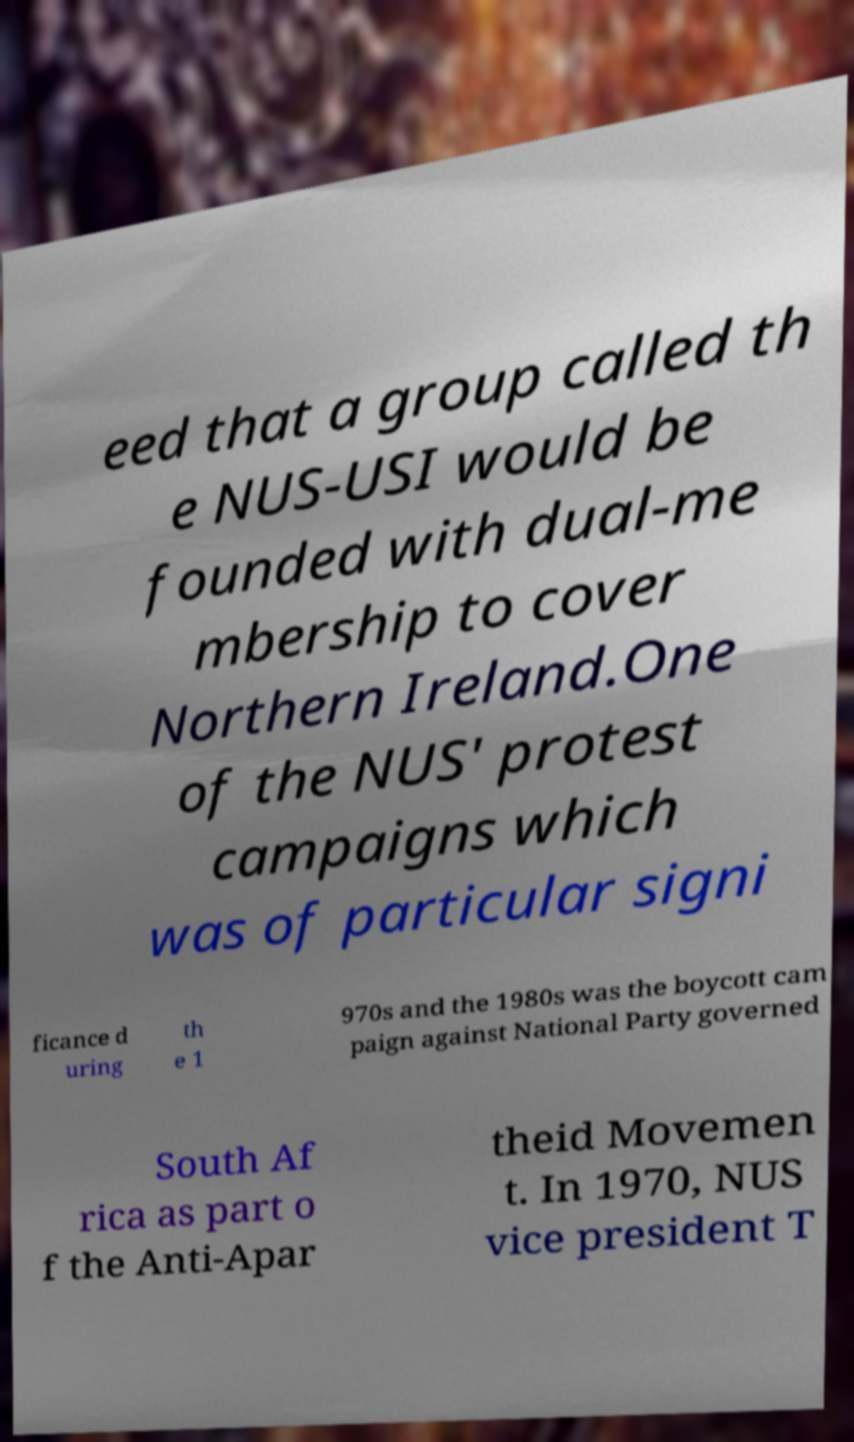There's text embedded in this image that I need extracted. Can you transcribe it verbatim? eed that a group called th e NUS-USI would be founded with dual-me mbership to cover Northern Ireland.One of the NUS' protest campaigns which was of particular signi ficance d uring th e 1 970s and the 1980s was the boycott cam paign against National Party governed South Af rica as part o f the Anti-Apar theid Movemen t. In 1970, NUS vice president T 